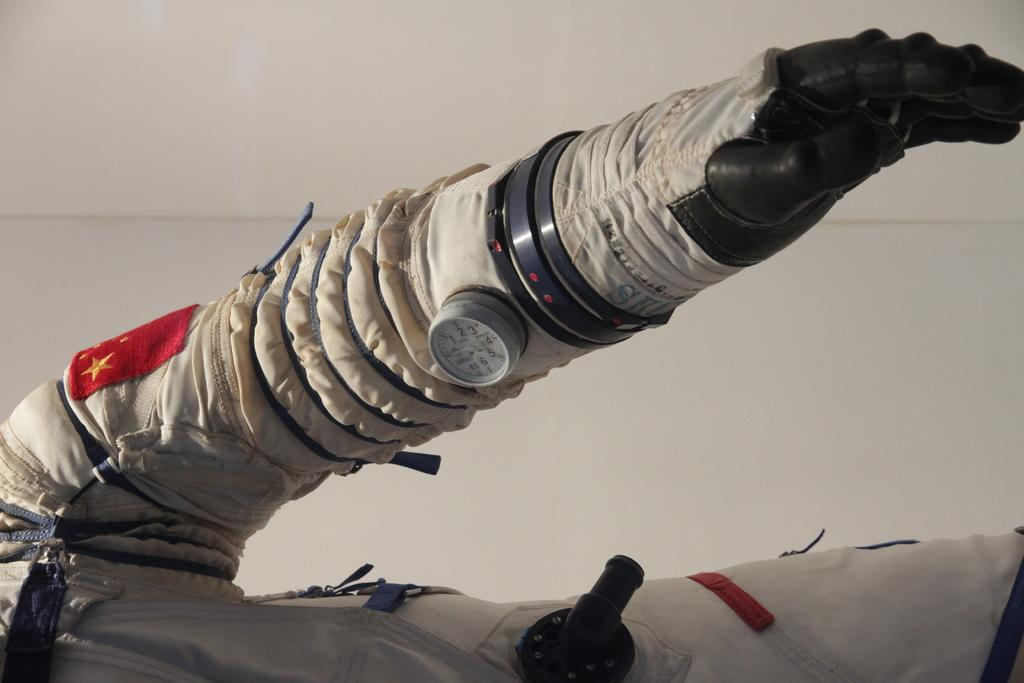What is the main subject of the image? There is a person in the image. What is the person wearing in the image? The person is wearing gloves. What object is the person holding in the image? The person is holding a meter. What type of behavior is the dog exhibiting in the image? There is no dog present in the image. What game is the person playing in the image? There is no game being played in the image; the person is simply holding a meter. 